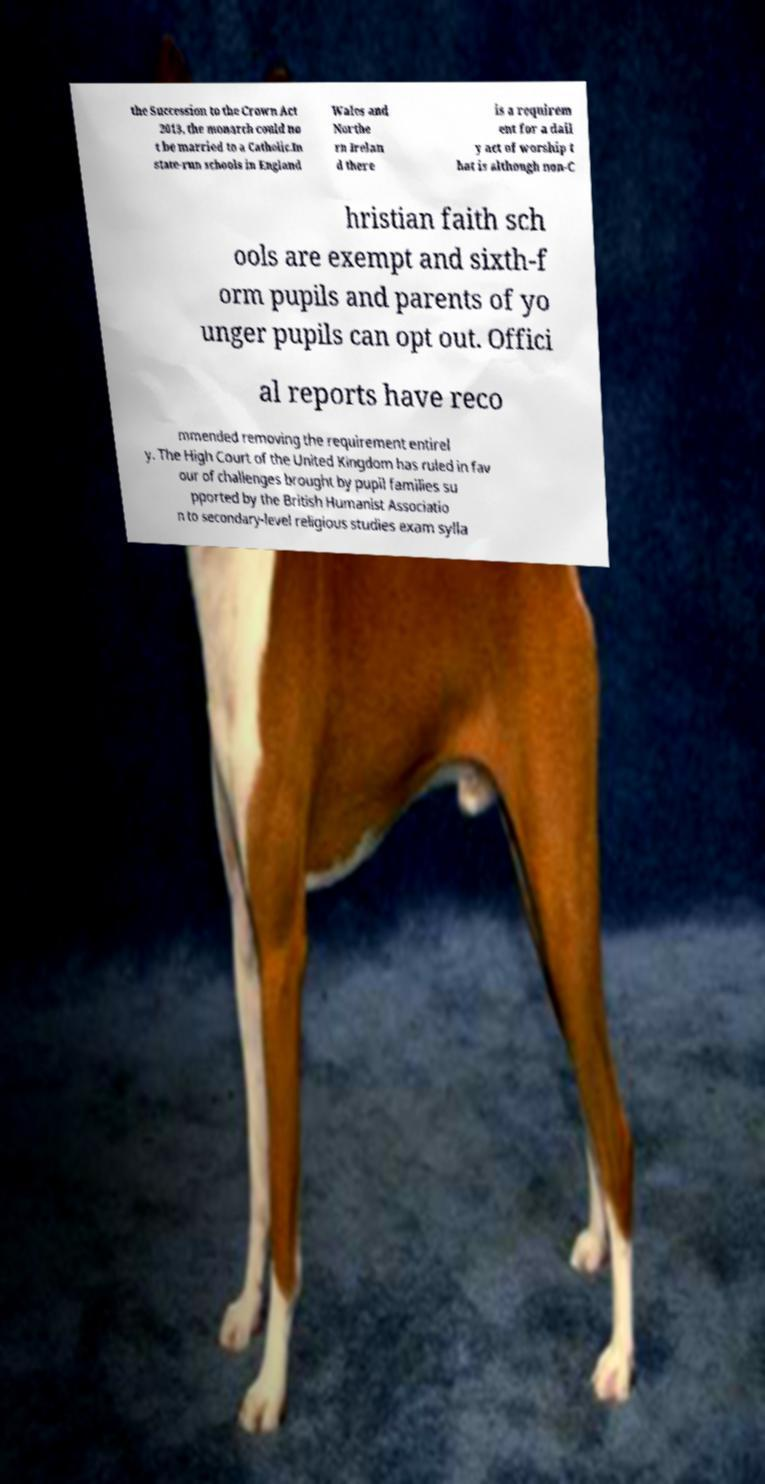For documentation purposes, I need the text within this image transcribed. Could you provide that? the Succession to the Crown Act 2013, the monarch could no t be married to a Catholic.In state-run schools in England Wales and Northe rn Irelan d there is a requirem ent for a dail y act of worship t hat is although non-C hristian faith sch ools are exempt and sixth-f orm pupils and parents of yo unger pupils can opt out. Offici al reports have reco mmended removing the requirement entirel y. The High Court of the United Kingdom has ruled in fav our of challenges brought by pupil families su pported by the British Humanist Associatio n to secondary-level religious studies exam sylla 